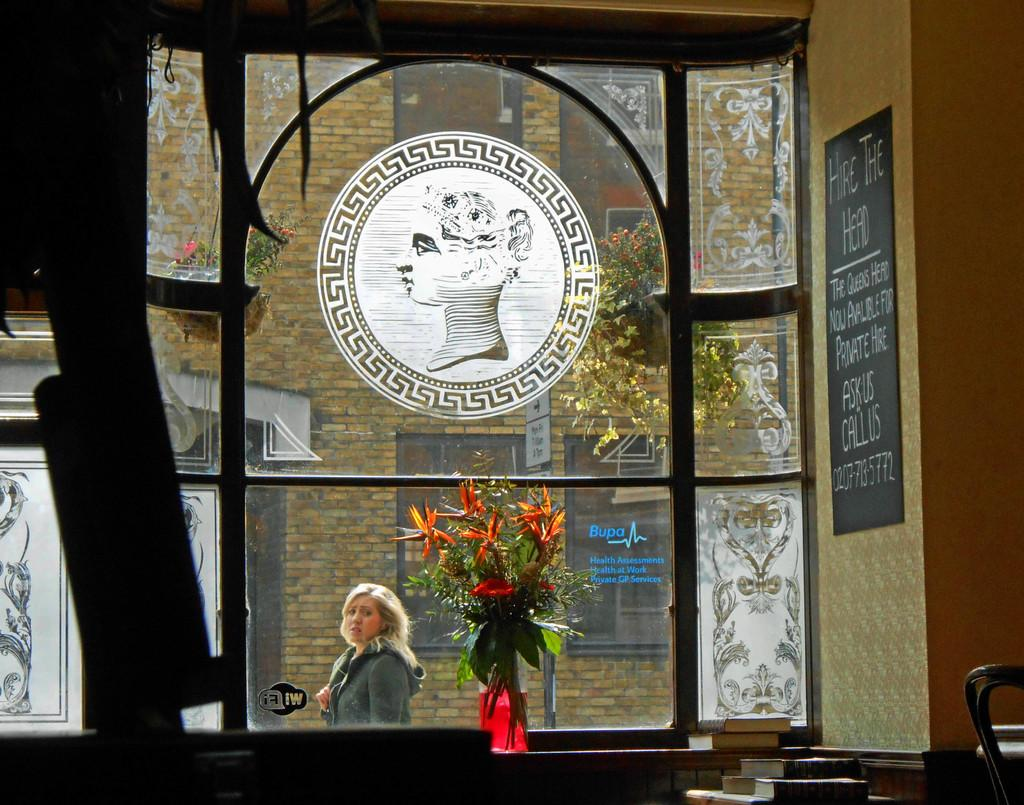<image>
Write a terse but informative summary of the picture. A window looks out to the street and the sign on he right reads "Hire the Head". 